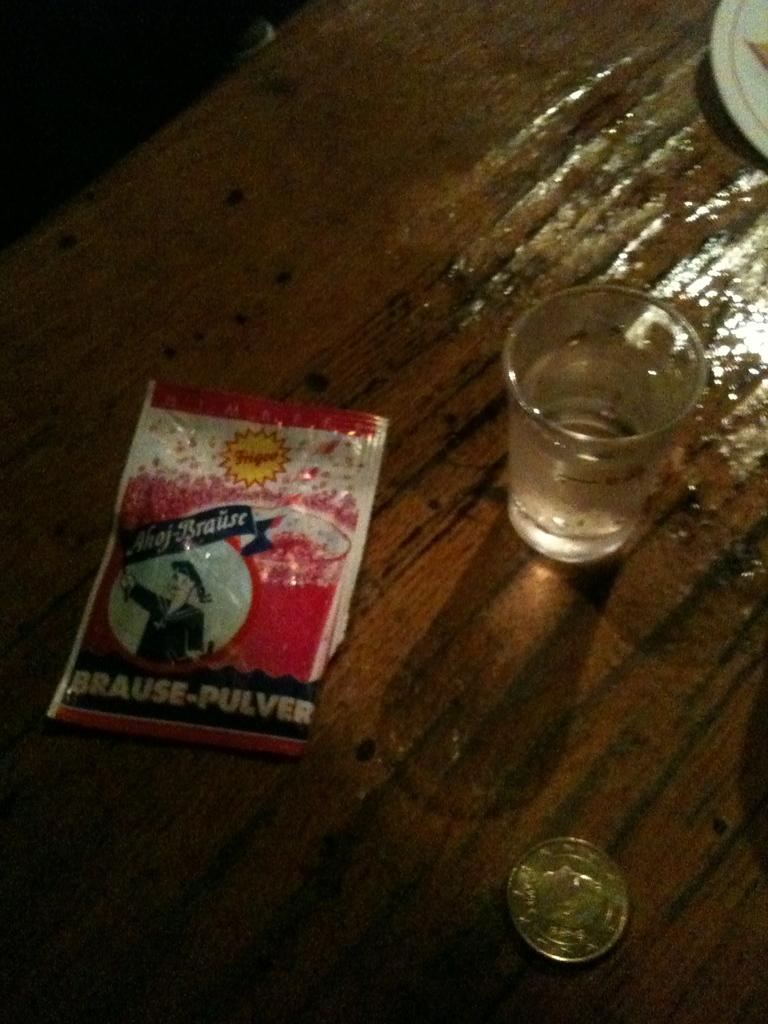<image>
Share a concise interpretation of the image provided. A packet marked Brause-Pulver is laying next to a shot glass. 